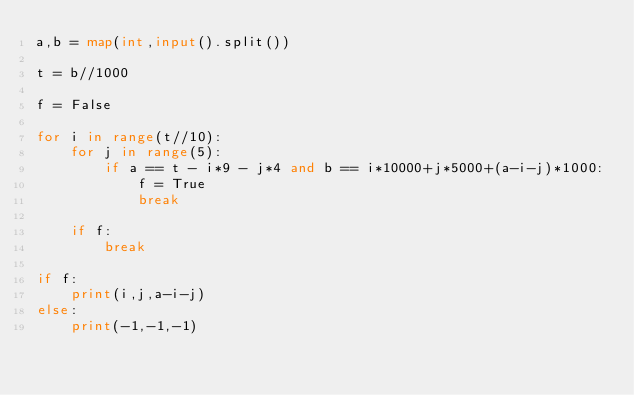<code> <loc_0><loc_0><loc_500><loc_500><_Python_>a,b = map(int,input().split())

t = b//1000

f = False

for i in range(t//10):
    for j in range(5):
        if a == t - i*9 - j*4 and b == i*10000+j*5000+(a-i-j)*1000:
            f = True
            break

    if f:
        break

if f:
    print(i,j,a-i-j)
else:
    print(-1,-1,-1)</code> 